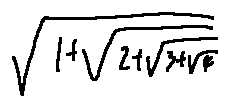Convert formula to latex. <formula><loc_0><loc_0><loc_500><loc_500>\sqrt { 1 + \sqrt { 2 + \sqrt { 3 + \sqrt { 4 } } } }</formula> 